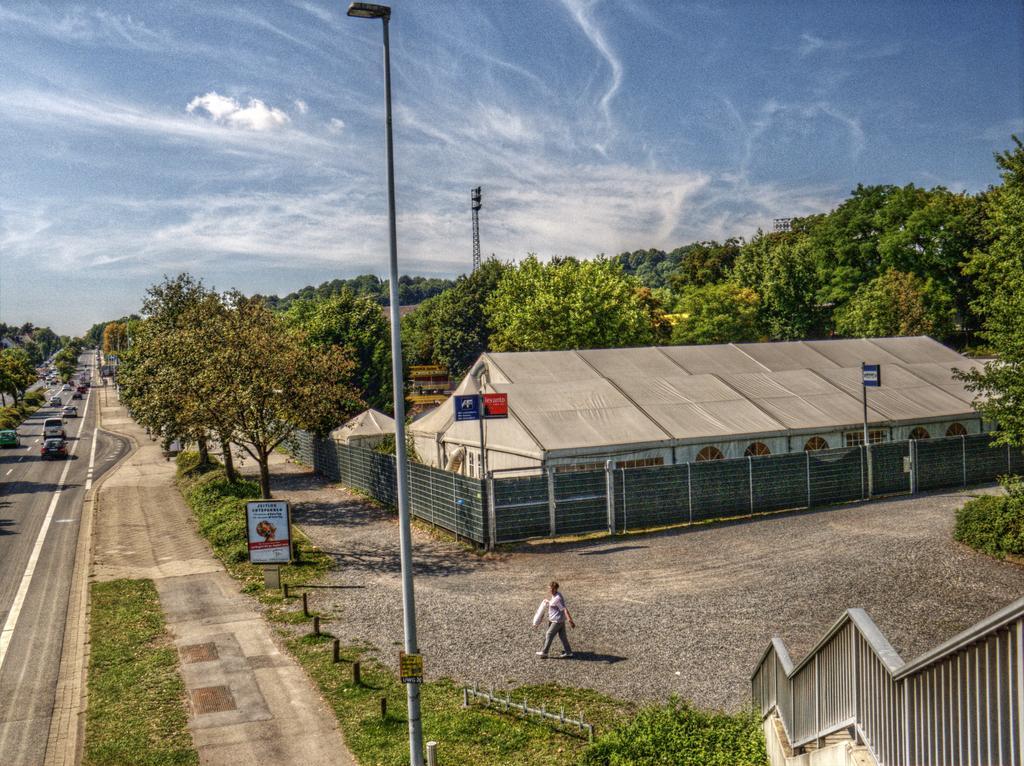Can you describe this image briefly? In the picture I can see a building, a person walking on the ground, trees, poles, the grass and fence. In the background I can see vehicles on the road and the sky. 